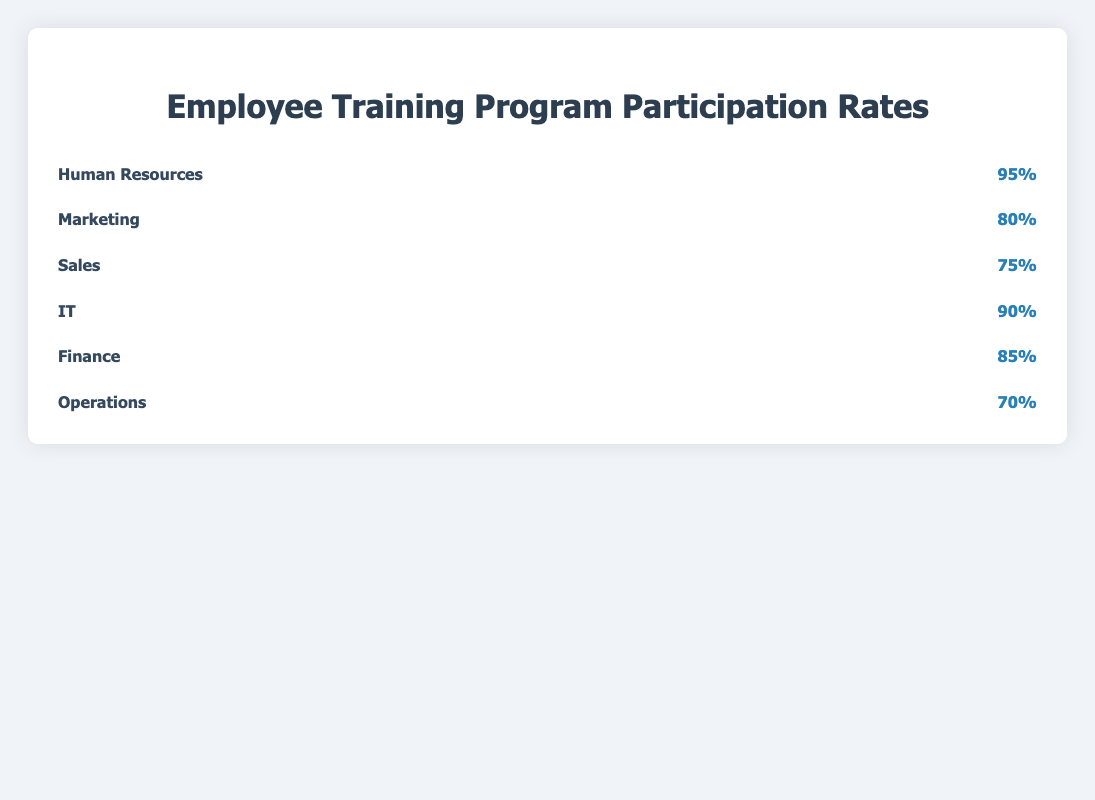What's the participation rate for the IT department? Locate the row for the IT department and read the percentage value in the "participation-rate" column.
Answer: 90% Which department has the highest training program participation rate? Compare the participation rates for all departments. The highest value is 95% for the Human Resources department.
Answer: Human Resources Which department has the lowest training program participation rate? Compare the participation rates for all departments. The lowest value is 70% for the Operations department.
Answer: Operations What is the combined participation rate for Marketing and Sales departments? Locate the participation rates for Marketing (80%) and Sales (75%). Add them together: 80% + 75% = 155%.
Answer: 155% Are there any departments with a participation rate above 90%? If so, which ones? Identify departments with participation rates greater than 90%. Only Human Resources at 95% meet this criterion.
Answer: Human Resources By how much does the participation rate of Finance exceed that of Operations? Calculate the difference between Finance (85%) and Operations (70%): 85% - 70% = 15%.
Answer: 15% How many icons represent the participation rate for the Marketing department? The icons represent participation rates in increments of 10%. For Marketing, with a rate of 80%, there are 8 icons.
Answer: 8 Which department uses a calculator icon? Identify the icon associated with the Finance department.
Answer: Finance List the departments in ascending order of their participation rates. Arrange the participation rates: Operations (70%), Sales (75%), Marketing (80%), Finance (85%), IT (90%), Human Resources (95%).
Answer: Operations, Sales, Marketing, Finance, IT, Human Resources How many more icons does the Human Resources department have compared to the Sales department? Calculate the difference in the number of icons: Human Resources (95/10 = 9.5, rounded to 10 icons) and Sales (75/10 = 7.5, rounded to 8 icons). Difference: 10 - 8 = 2 icons.
Answer: 2 